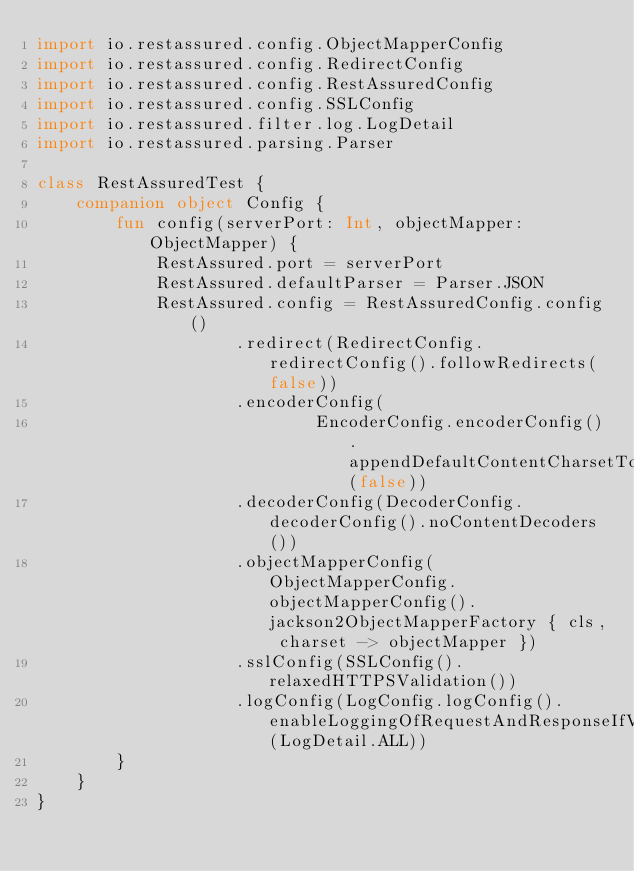<code> <loc_0><loc_0><loc_500><loc_500><_Kotlin_>import io.restassured.config.ObjectMapperConfig
import io.restassured.config.RedirectConfig
import io.restassured.config.RestAssuredConfig
import io.restassured.config.SSLConfig
import io.restassured.filter.log.LogDetail
import io.restassured.parsing.Parser

class RestAssuredTest {
    companion object Config {
        fun config(serverPort: Int, objectMapper: ObjectMapper) {
            RestAssured.port = serverPort
            RestAssured.defaultParser = Parser.JSON
            RestAssured.config = RestAssuredConfig.config()
                    .redirect(RedirectConfig.redirectConfig().followRedirects(false))
                    .encoderConfig(
                            EncoderConfig.encoderConfig().appendDefaultContentCharsetToContentTypeIfUndefined(false))
                    .decoderConfig(DecoderConfig.decoderConfig().noContentDecoders())
                    .objectMapperConfig(ObjectMapperConfig.objectMapperConfig().jackson2ObjectMapperFactory { cls, charset -> objectMapper })
                    .sslConfig(SSLConfig().relaxedHTTPSValidation())
                    .logConfig(LogConfig.logConfig().enableLoggingOfRequestAndResponseIfValidationFails(LogDetail.ALL))
        }
    }
}
</code> 